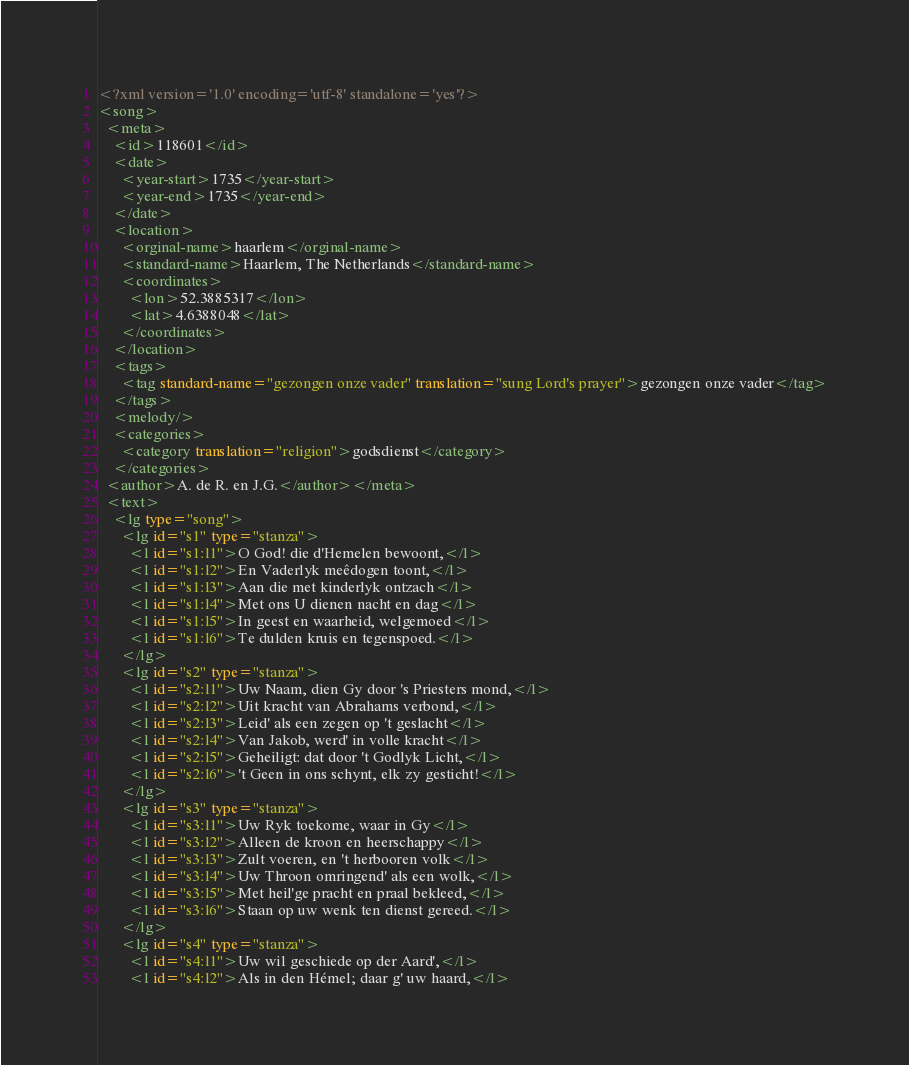Convert code to text. <code><loc_0><loc_0><loc_500><loc_500><_XML_><?xml version='1.0' encoding='utf-8' standalone='yes'?>
<song>
  <meta>
    <id>118601</id>
    <date>
      <year-start>1735</year-start>
      <year-end>1735</year-end>
    </date>
    <location>
      <orginal-name>haarlem</orginal-name>
      <standard-name>Haarlem, The Netherlands</standard-name>
      <coordinates>
        <lon>52.3885317</lon>
        <lat>4.6388048</lat>
      </coordinates>
    </location>
    <tags>
      <tag standard-name="gezongen onze vader" translation="sung Lord's prayer">gezongen onze vader</tag>
    </tags>
    <melody/>
    <categories>
      <category translation="religion">godsdienst</category>
    </categories>
  <author>A. de R. en J.G.</author></meta>
  <text>
    <lg type="song">
      <lg id="s1" type="stanza">
        <l id="s1:l1">O God! die d'Hemelen bewoont,</l>
        <l id="s1:l2">En Vaderlyk meêdogen toont,</l>
        <l id="s1:l3">Aan die met kinderlyk ontzach</l>
        <l id="s1:l4">Met ons U dienen nacht en dag</l>
        <l id="s1:l5">In geest en waarheid, welgemoed</l>
        <l id="s1:l6">Te dulden kruis en tegenspoed.</l>
      </lg>
      <lg id="s2" type="stanza">
        <l id="s2:l1">Uw Naam, dien Gy door 's Priesters mond,</l>
        <l id="s2:l2">Uit kracht van Abrahams verbond,</l>
        <l id="s2:l3">Leid' als een zegen op 't geslacht</l>
        <l id="s2:l4">Van Jakob, werd' in volle kracht</l>
        <l id="s2:l5">Geheiligt: dat door 't Godlyk Licht,</l>
        <l id="s2:l6">'t Geen in ons schynt, elk zy gesticht!</l>
      </lg>
      <lg id="s3" type="stanza">
        <l id="s3:l1">Uw Ryk toekome, waar in Gy</l>
        <l id="s3:l2">Alleen de kroon en heerschappy</l>
        <l id="s3:l3">Zult voeren, en 't herbooren volk</l>
        <l id="s3:l4">Uw Throon omringend' als een wolk,</l>
        <l id="s3:l5">Met heil'ge pracht en praal bekleed,</l>
        <l id="s3:l6">Staan op uw wenk ten dienst gereed.</l>
      </lg>
      <lg id="s4" type="stanza">
        <l id="s4:l1">Uw wil geschiede op der Aard',</l>
        <l id="s4:l2">Als in den Hémel; daar g' uw haard,</l></code> 